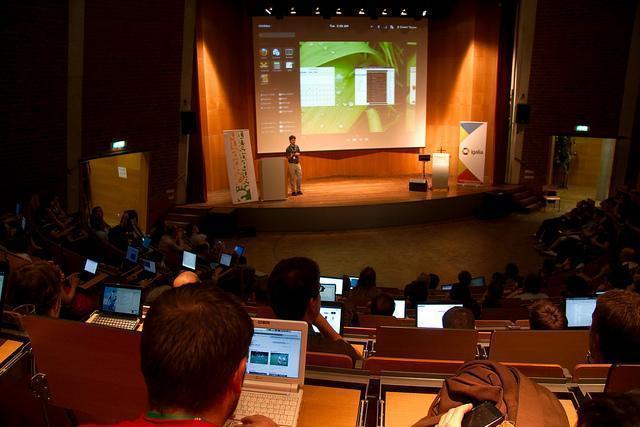What type of classroom could this be called?
Indicate the correct response by choosing from the four available options to answer the question.
Options: Podium, amphitheater, stadium, enclave. Stadium. 